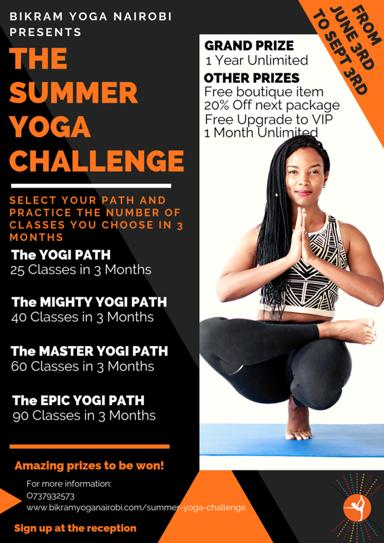How can someone sign up for the Summer Yoga Challenge? Enthusiasts eager to join the Summer Yoga Challenge can easily sign up by visiting the reception at Bikram Yoga Nairobi or by calling the studio directly at 0737932578. For more details, participants can also explore the challenge’s offerings on their official website at www.bikramyoganairobi.com, ensuring they don’t miss out on this exciting opportunity. 